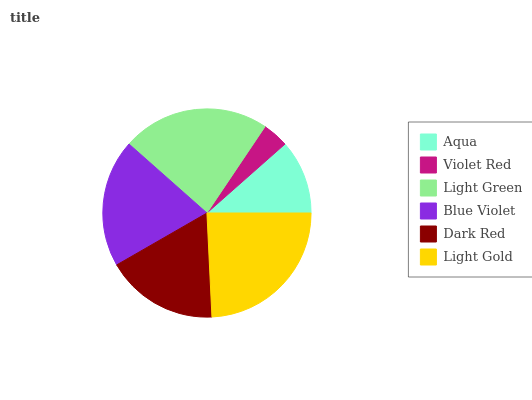Is Violet Red the minimum?
Answer yes or no. Yes. Is Light Gold the maximum?
Answer yes or no. Yes. Is Light Green the minimum?
Answer yes or no. No. Is Light Green the maximum?
Answer yes or no. No. Is Light Green greater than Violet Red?
Answer yes or no. Yes. Is Violet Red less than Light Green?
Answer yes or no. Yes. Is Violet Red greater than Light Green?
Answer yes or no. No. Is Light Green less than Violet Red?
Answer yes or no. No. Is Blue Violet the high median?
Answer yes or no. Yes. Is Dark Red the low median?
Answer yes or no. Yes. Is Aqua the high median?
Answer yes or no. No. Is Light Gold the low median?
Answer yes or no. No. 